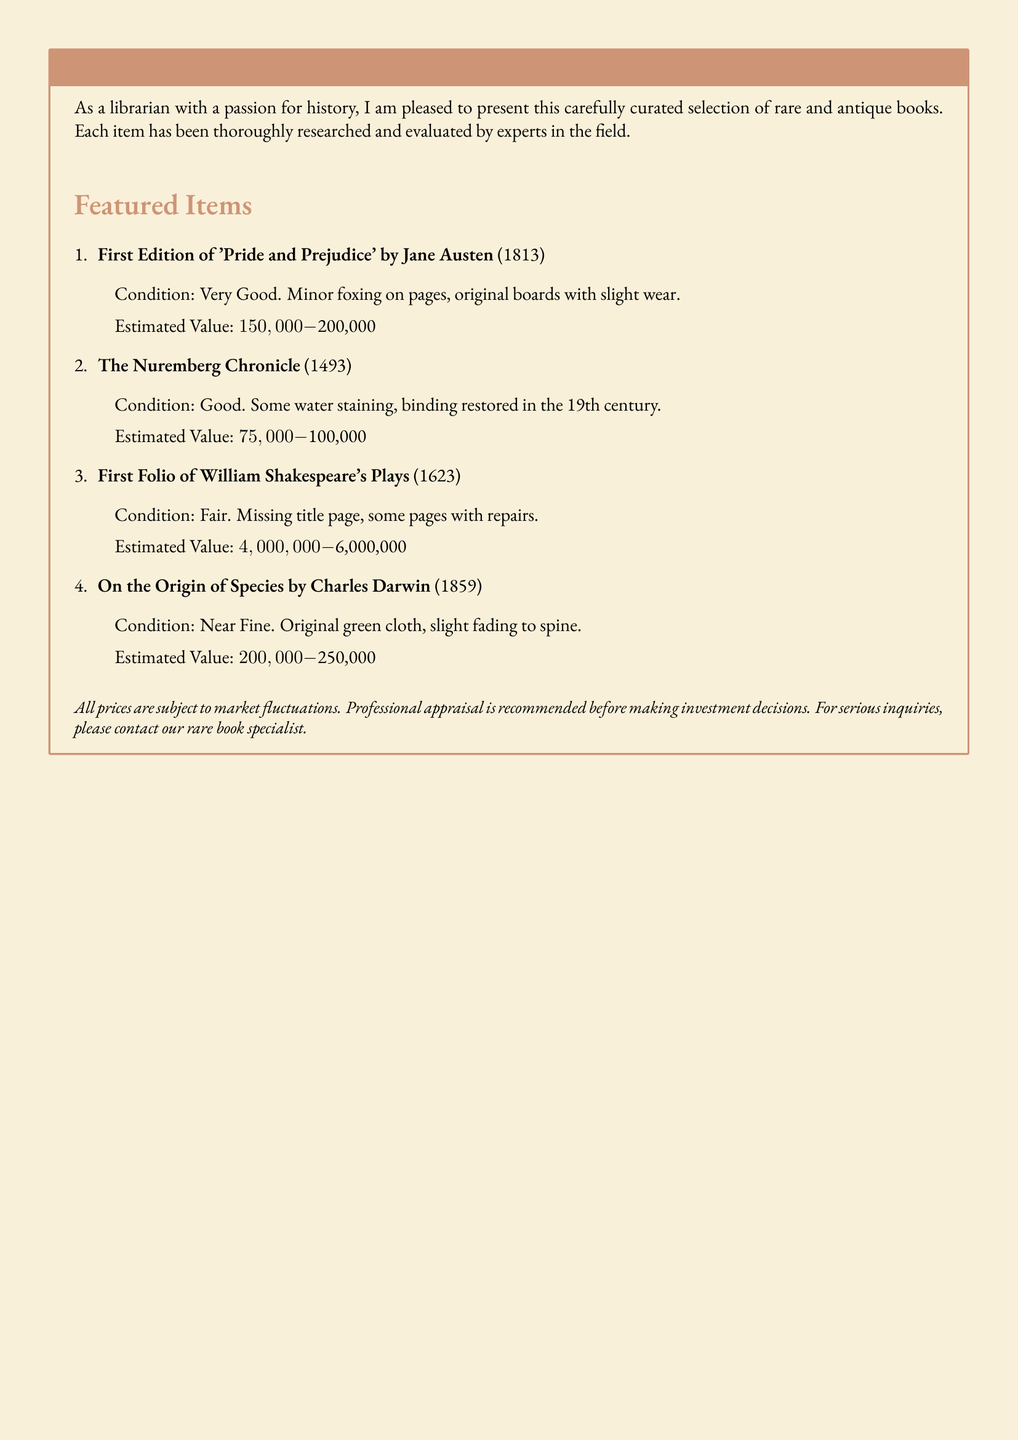What is the title of the first book listed? The title of the first book listed in the catalog is 'Pride and Prejudice' by Jane Austen.
Answer: 'Pride and Prejudice' What year was 'The Nuremberg Chronicle' published? The Nuremberg Chronicle was published in 1493.
Answer: 1493 What is the estimated value range for the First Folio of William Shakespeare's Plays? The estimated value range for the First Folio is $4,000,000 - $6,000,000.
Answer: $4,000,000 - $6,000,000 What condition is described for 'On the Origin of Species'? 'On the Origin of Species' is described as Near Fine.
Answer: Near Fine Which book has suffered missing parts? The book that has missing parts is the First Folio of William Shakespeare's Plays.
Answer: First Folio of William Shakespeare's Plays How many rare and antique books are featured in the document? There are four rare and antique books featured in the document.
Answer: Four What is the condition of 'The Nuremberg Chronicle'? The condition of 'The Nuremberg Chronicle' is Good.
Answer: Good What is recommended before making investment decisions? A professional appraisal is recommended before making investment decisions.
Answer: Professional appraisal 